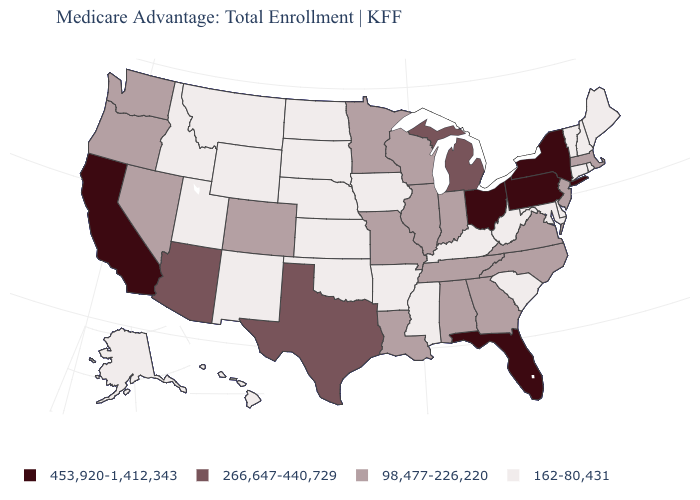Among the states that border Connecticut , does New York have the lowest value?
Short answer required. No. Name the states that have a value in the range 453,920-1,412,343?
Concise answer only. California, Florida, New York, Ohio, Pennsylvania. Which states have the lowest value in the USA?
Concise answer only. Alaska, Arkansas, Connecticut, Delaware, Hawaii, Iowa, Idaho, Kansas, Kentucky, Maryland, Maine, Mississippi, Montana, North Dakota, Nebraska, New Hampshire, New Mexico, Oklahoma, Rhode Island, South Carolina, South Dakota, Utah, Vermont, West Virginia, Wyoming. What is the value of Maryland?
Answer briefly. 162-80,431. Name the states that have a value in the range 266,647-440,729?
Short answer required. Arizona, Michigan, Texas. Does Connecticut have the lowest value in the USA?
Write a very short answer. Yes. Which states hav the highest value in the West?
Short answer required. California. What is the value of Alabama?
Be succinct. 98,477-226,220. What is the value of South Dakota?
Keep it brief. 162-80,431. Does the first symbol in the legend represent the smallest category?
Short answer required. No. What is the value of Georgia?
Write a very short answer. 98,477-226,220. What is the highest value in the USA?
Concise answer only. 453,920-1,412,343. Name the states that have a value in the range 266,647-440,729?
Keep it brief. Arizona, Michigan, Texas. Name the states that have a value in the range 453,920-1,412,343?
Write a very short answer. California, Florida, New York, Ohio, Pennsylvania. Does Massachusetts have the lowest value in the USA?
Be succinct. No. 